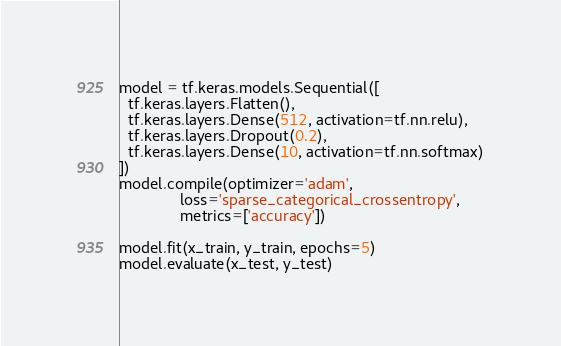Convert code to text. <code><loc_0><loc_0><loc_500><loc_500><_Python_>model = tf.keras.models.Sequential([
  tf.keras.layers.Flatten(),
  tf.keras.layers.Dense(512, activation=tf.nn.relu),
  tf.keras.layers.Dropout(0.2),
  tf.keras.layers.Dense(10, activation=tf.nn.softmax)
])
model.compile(optimizer='adam',
              loss='sparse_categorical_crossentropy',
              metrics=['accuracy'])

model.fit(x_train, y_train, epochs=5)
model.evaluate(x_test, y_test)</code> 